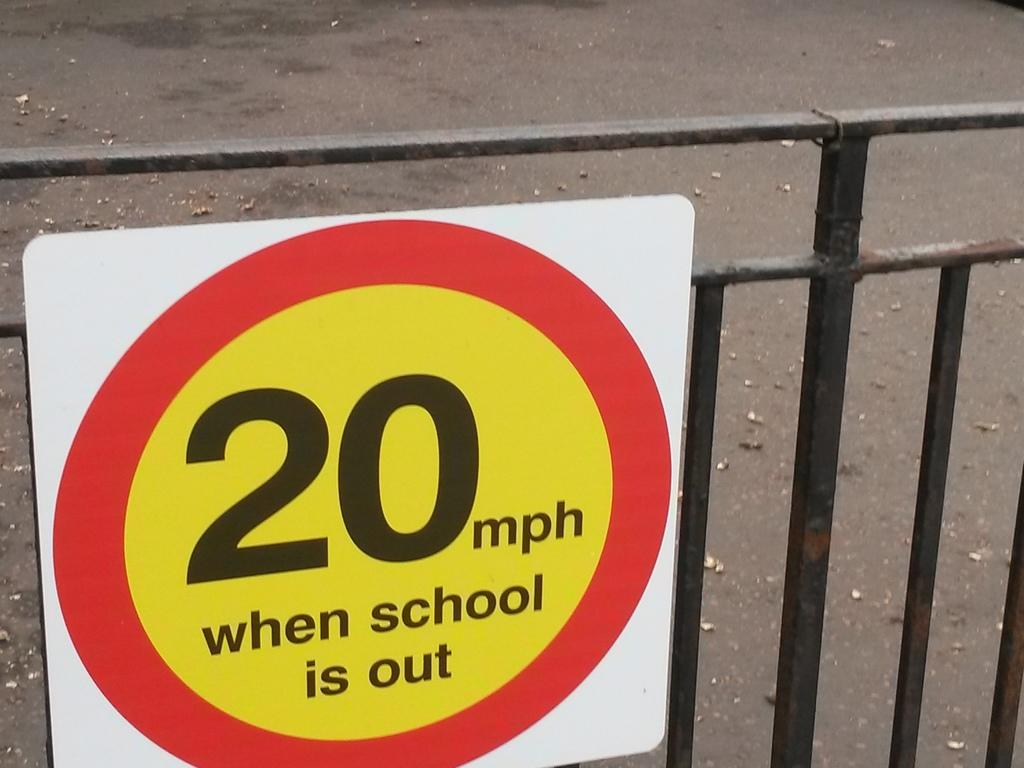<image>
Provide a brief description of the given image. A sign on a fence says 20 mph when school is out. 